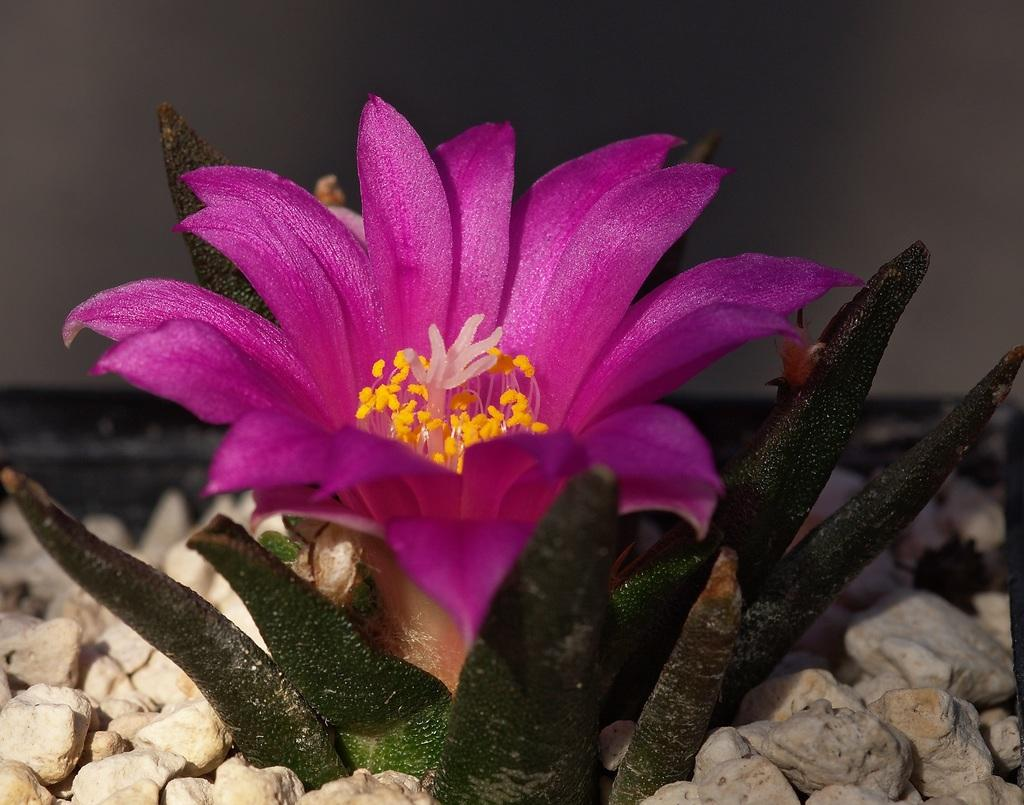What type of plant can be seen in the image? There is a flower in the image. What else is present on the plant besides the flower? There are leaves in the image. What other objects can be seen in the image? There are stones in the image. Can you describe the background of the image? The background of the image is blurred. What is the opinion of the plate about the art in the image? There is no plate present in the image, and therefore no opinion can be attributed to it. 